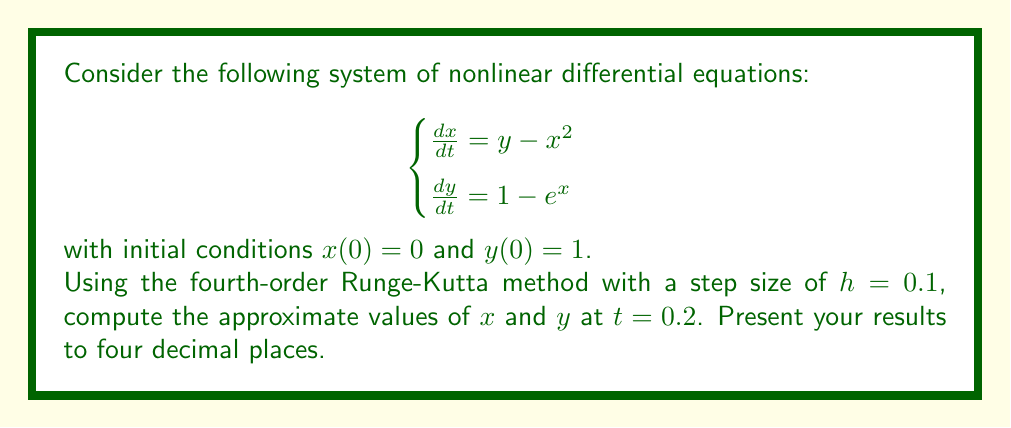Can you solve this math problem? To solve this system using the fourth-order Runge-Kutta method, we'll follow these steps:

1) Define the functions for $\frac{dx}{dt}$ and $\frac{dy}{dt}$:
   $f(x,y) = y - x^2$
   $g(x,y) = 1 - e^x$

2) The fourth-order Runge-Kutta method for a system of two equations is:

   $$\begin{align}
   x_{n+1} &= x_n + \frac{1}{6}(k_1 + 2k_2 + 2k_3 + k_4) \\
   y_{n+1} &= y_n + \frac{1}{6}(l_1 + 2l_2 + 2l_3 + l_4)
   \end{align}$$

   where:
   $$\begin{align}
   k_1 &= hf(x_n, y_n) \\
   l_1 &= hg(x_n, y_n) \\
   k_2 &= hf(x_n + \frac{k_1}{2}, y_n + \frac{l_1}{2}) \\
   l_2 &= hg(x_n + \frac{k_1}{2}, y_n + \frac{l_1}{2}) \\
   k_3 &= hf(x_n + \frac{k_2}{2}, y_n + \frac{l_2}{2}) \\
   l_3 &= hg(x_n + \frac{k_2}{2}, y_n + \frac{l_2}{2}) \\
   k_4 &= hf(x_n + k_3, y_n + l_3) \\
   l_4 &= hg(x_n + k_3, y_n + l_3)
   \end{align}$$

3) We need to perform two iterations to reach $t = 0.2$ with $h = 0.1$. Let's start with the first iteration:

   Initial values: $x_0 = 0$, $y_0 = 1$, $h = 0.1$

   $$\begin{align}
   k_1 &= 0.1(1 - 0^2) = 0.1 \\
   l_1 &= 0.1(1 - e^0) = 0 \\
   k_2 &= 0.1((1 + 0/2) - (0 + 0.1/2)^2) \approx 0.09975 \\
   l_2 &= 0.1(1 - e^{0.05}) \approx -0.00513 \\
   k_3 &= 0.1((1 - 0.00513/2) - (0 + 0.09975/2)^2) \approx 0.09950 \\
   l_3 &= 0.1(1 - e^{0.049875}) \approx -0.00511 \\
   k_4 &= 0.1((1 - 0.00511) - (0 + 0.09950)^2) \approx 0.08940 \\
   l_4 &= 0.1(1 - e^{0.09950}) \approx -0.01045
   \end{align}$$

   $$\begin{align}
   x_1 &= 0 + \frac{1}{6}(0.1 + 2(0.09975) + 2(0.09950) + 0.08940) \approx 0.09965 \\
   y_1 &= 1 + \frac{1}{6}(0 + 2(-0.00513) + 2(-0.00511) - 0.01045) \approx 0.99487
   \end{align}$$

4) For the second iteration, we use $x_1$ and $y_1$ as our new starting points:

   $$\begin{align}
   k_1 &= 0.1(0.99487 - 0.09965^2) \approx 0.09053 \\
   l_1 &= 0.1(1 - e^{0.09965}) \approx -0.01047 \\
   k_2 &\approx 0.08996 \\
   l_2 &\approx -0.01102 \\
   k_3 &\approx 0.08970 \\
   l_3 &\approx -0.01105 \\
   k_4 &\approx 0.07909 \\
   l_4 &\approx -0.01164
   \end{align}$$

   $$\begin{align}
   x_2 &\approx 0.09965 + \frac{1}{6}(0.09053 + 2(0.08996) + 2(0.08970) + 0.07909) \approx 0.18941 \\
   y_2 &\approx 0.99487 + \frac{1}{6}(-0.01047 + 2(-0.01102) + 2(-0.01105) - 0.01164) \approx 0.98381
   \end{align}$$

Therefore, at $t = 0.2$, we have $x \approx 0.1894$ and $y \approx 0.9838$ (to four decimal places).
Answer: $x(0.2) \approx 0.1894$, $y(0.2) \approx 0.9838$ 